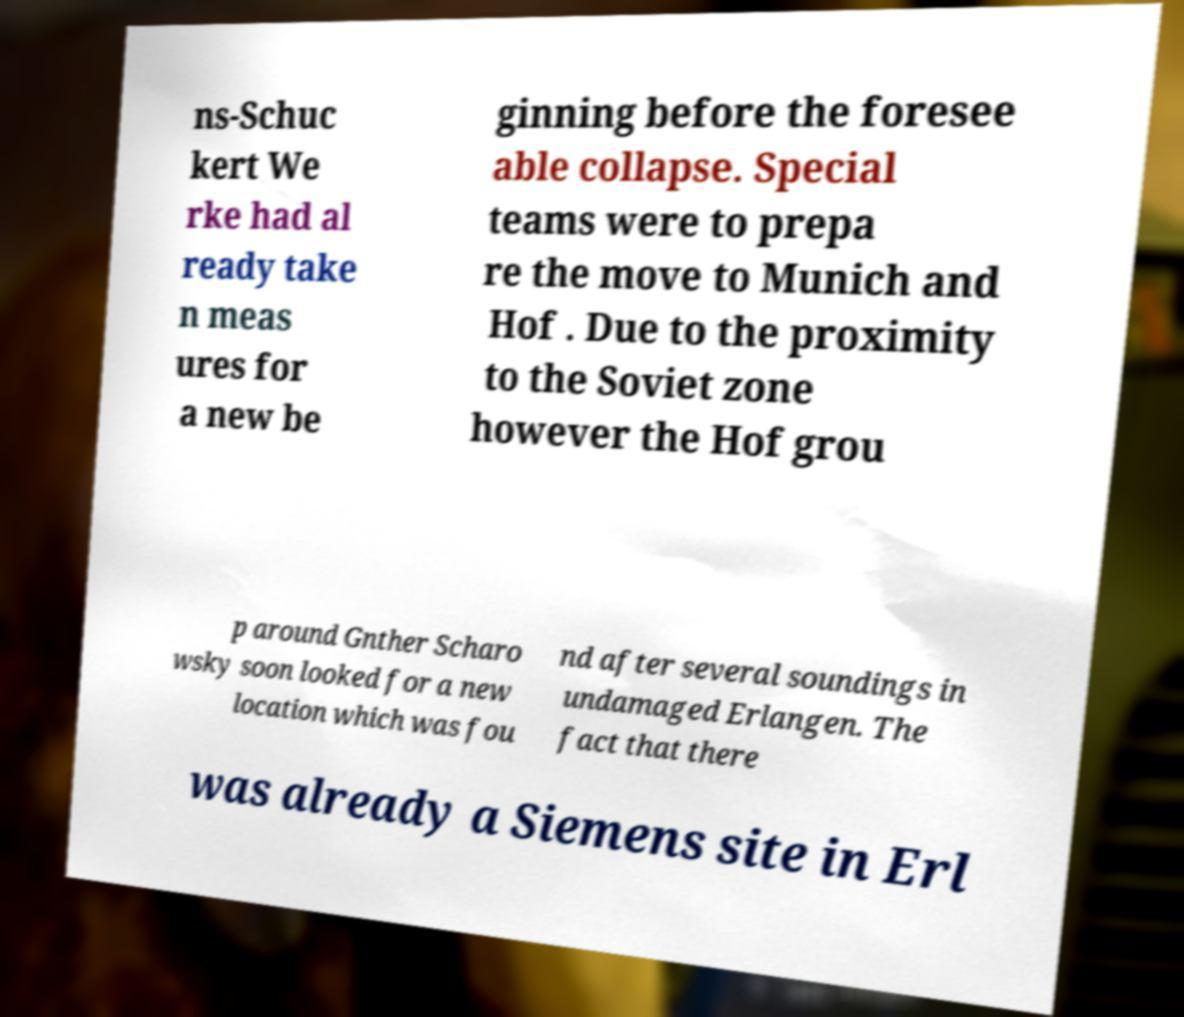There's text embedded in this image that I need extracted. Can you transcribe it verbatim? ns-Schuc kert We rke had al ready take n meas ures for a new be ginning before the foresee able collapse. Special teams were to prepa re the move to Munich and Hof . Due to the proximity to the Soviet zone however the Hof grou p around Gnther Scharo wsky soon looked for a new location which was fou nd after several soundings in undamaged Erlangen. The fact that there was already a Siemens site in Erl 